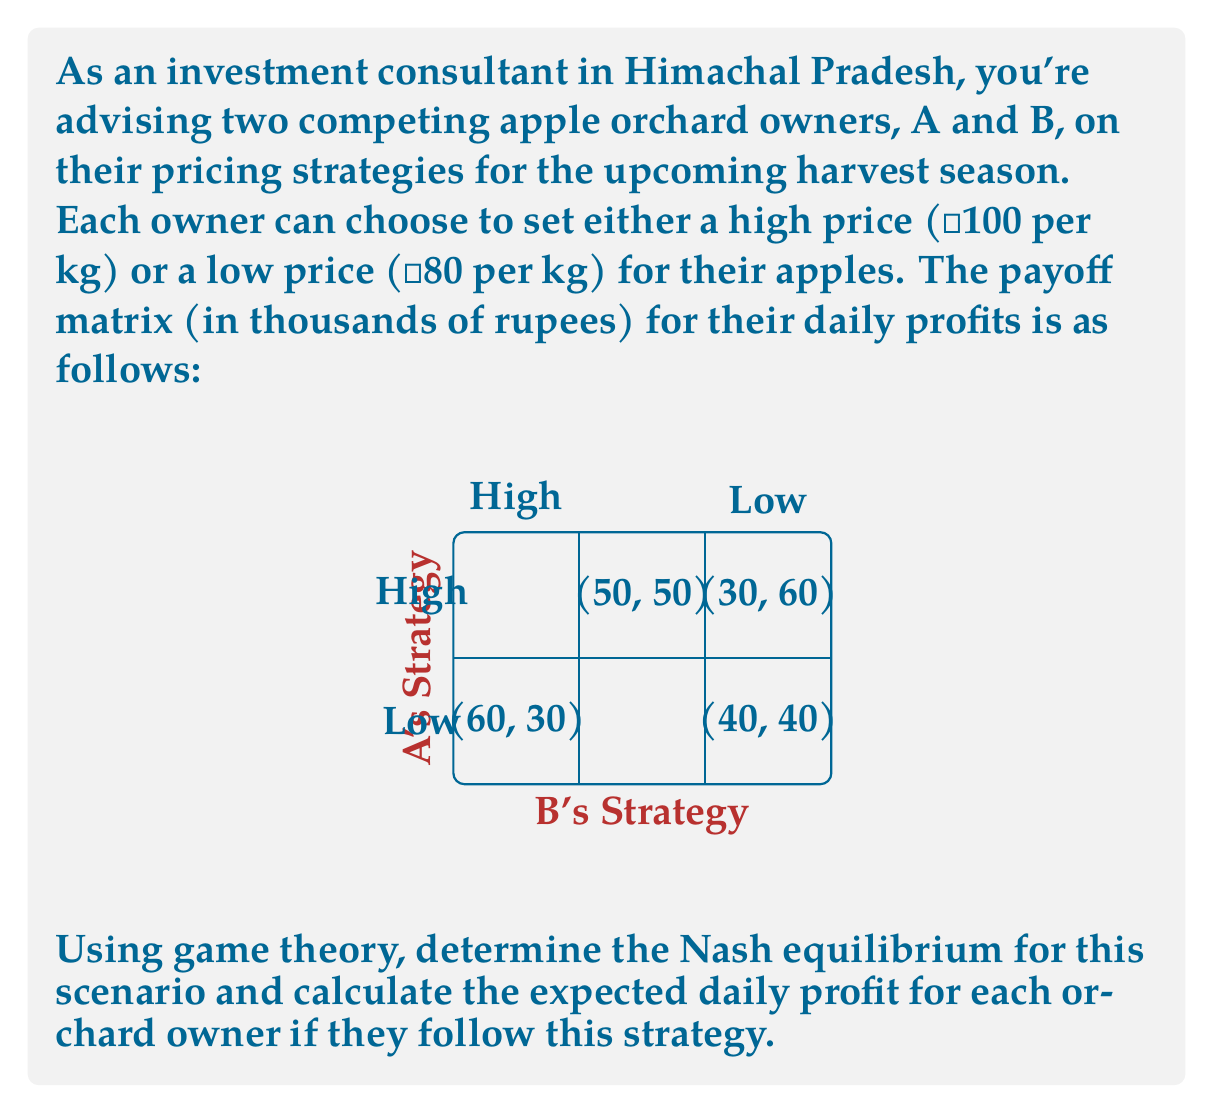Teach me how to tackle this problem. Let's approach this problem step-by-step using game theory concepts:

1) First, we need to identify the Nash equilibrium. A Nash equilibrium occurs when neither player can unilaterally improve their outcome by changing their strategy.

2) Let's analyze each player's best responses:

   For A:
   - If B chooses High: A's best response is Low (60 > 50)
   - If B chooses Low: A's best response is High (30 > 40)

   For B:
   - If A chooses High: B's best response is Low (60 > 50)
   - If A chooses Low: B's best response is High (40 > 30)

3) We can see that there's no pure strategy Nash equilibrium, as there's no cell where both players are playing their best responses simultaneously.

4) In this case, we need to look for a mixed strategy Nash equilibrium. Let's define:
   $p$ = probability of A choosing High
   $q$ = probability of B choosing High

5) For this to be an equilibrium, each player must be indifferent between their strategies. We can set up equations:

   For A: $50q + 30(1-q) = 60q + 40(1-q)$
   For B: $50p + 60(1-p) = 30p + 40(1-p)$

6) Solving these equations:
   $20q = 10$ → $q = \frac{1}{2}$
   $20p = 20$ → $p = 1$

7) However, $p = 1$ doesn't make sense in this context. Let's solve for B's indifference:
   $50p + 30(1-p) = 60p + 40(1-p)$
   $20p = 10$ → $p = \frac{1}{2}$

8) Therefore, the mixed strategy Nash equilibrium is $(p, q) = (\frac{1}{2}, \frac{1}{2})$

9) To calculate the expected daily profit for each owner:

   For A: $E(A) = \frac{1}{2}(\frac{1}{2} \cdot 50 + \frac{1}{2} \cdot 30) + \frac{1}{2}(\frac{1}{2} \cdot 60 + \frac{1}{2} \cdot 40) = 45$

   For B: $E(B) = \frac{1}{2}(\frac{1}{2} \cdot 50 + \frac{1}{2} \cdot 60) + \frac{1}{2}(\frac{1}{2} \cdot 30 + \frac{1}{2} \cdot 40) = 45$
Answer: Nash equilibrium: Both A and B choose High with probability $\frac{1}{2}$. Expected daily profit for each: ₹45,000. 